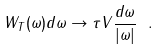<formula> <loc_0><loc_0><loc_500><loc_500>W _ { T } ( \omega ) d \omega \to \tau V \frac { d \omega } { | \omega | } \ .</formula> 